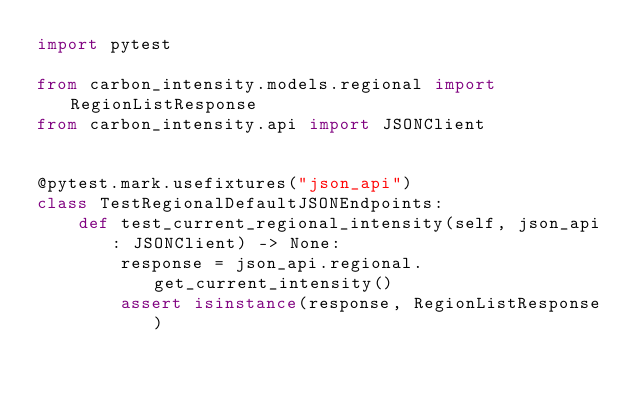Convert code to text. <code><loc_0><loc_0><loc_500><loc_500><_Python_>import pytest

from carbon_intensity.models.regional import RegionListResponse
from carbon_intensity.api import JSONClient


@pytest.mark.usefixtures("json_api")
class TestRegionalDefaultJSONEndpoints:
    def test_current_regional_intensity(self, json_api: JSONClient) -> None:
        response = json_api.regional.get_current_intensity()
        assert isinstance(response, RegionListResponse)
</code> 